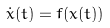<formula> <loc_0><loc_0><loc_500><loc_500>\dot { x } ( t ) = f ( x ( t ) )</formula> 